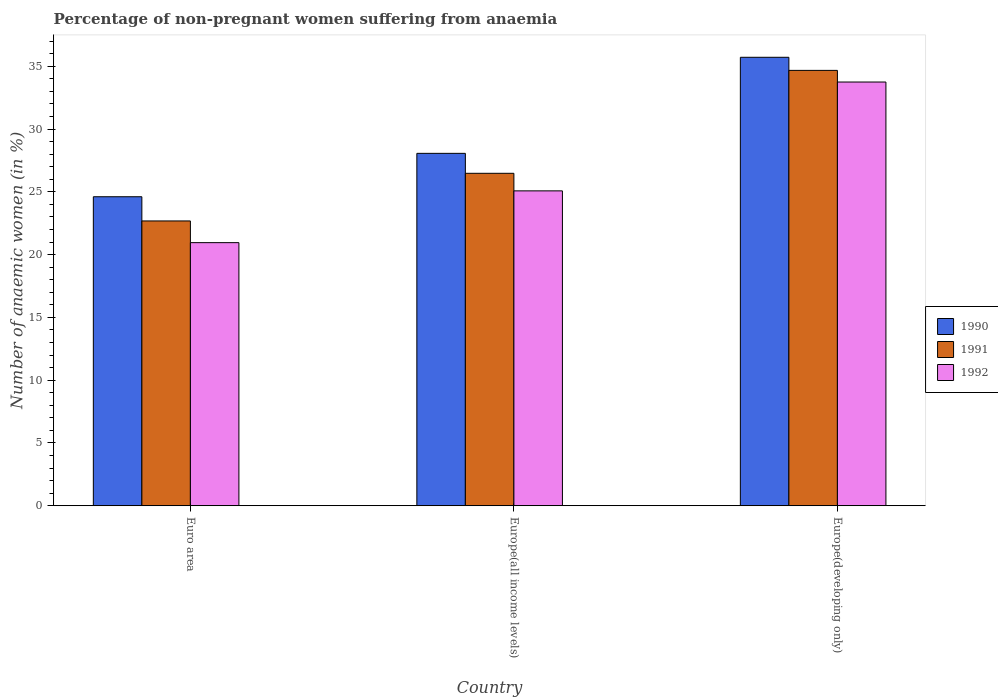How many groups of bars are there?
Keep it short and to the point. 3. What is the label of the 3rd group of bars from the left?
Offer a very short reply. Europe(developing only). What is the percentage of non-pregnant women suffering from anaemia in 1991 in Euro area?
Provide a short and direct response. 22.68. Across all countries, what is the maximum percentage of non-pregnant women suffering from anaemia in 1991?
Ensure brevity in your answer.  34.67. Across all countries, what is the minimum percentage of non-pregnant women suffering from anaemia in 1991?
Offer a very short reply. 22.68. In which country was the percentage of non-pregnant women suffering from anaemia in 1992 maximum?
Your answer should be compact. Europe(developing only). What is the total percentage of non-pregnant women suffering from anaemia in 1992 in the graph?
Keep it short and to the point. 79.77. What is the difference between the percentage of non-pregnant women suffering from anaemia in 1991 in Euro area and that in Europe(developing only)?
Provide a succinct answer. -11.99. What is the difference between the percentage of non-pregnant women suffering from anaemia in 1992 in Europe(developing only) and the percentage of non-pregnant women suffering from anaemia in 1991 in Europe(all income levels)?
Your answer should be compact. 7.27. What is the average percentage of non-pregnant women suffering from anaemia in 1991 per country?
Provide a succinct answer. 27.94. What is the difference between the percentage of non-pregnant women suffering from anaemia of/in 1990 and percentage of non-pregnant women suffering from anaemia of/in 1992 in Europe(developing only)?
Ensure brevity in your answer.  1.97. What is the ratio of the percentage of non-pregnant women suffering from anaemia in 1991 in Europe(all income levels) to that in Europe(developing only)?
Offer a very short reply. 0.76. Is the percentage of non-pregnant women suffering from anaemia in 1991 in Euro area less than that in Europe(developing only)?
Provide a short and direct response. Yes. What is the difference between the highest and the second highest percentage of non-pregnant women suffering from anaemia in 1991?
Ensure brevity in your answer.  8.2. What is the difference between the highest and the lowest percentage of non-pregnant women suffering from anaemia in 1991?
Offer a terse response. 11.99. What does the 2nd bar from the right in Europe(all income levels) represents?
Provide a short and direct response. 1991. How many bars are there?
Offer a terse response. 9. How are the legend labels stacked?
Provide a short and direct response. Vertical. What is the title of the graph?
Ensure brevity in your answer.  Percentage of non-pregnant women suffering from anaemia. What is the label or title of the X-axis?
Give a very brief answer. Country. What is the label or title of the Y-axis?
Make the answer very short. Number of anaemic women (in %). What is the Number of anaemic women (in %) of 1990 in Euro area?
Provide a short and direct response. 24.61. What is the Number of anaemic women (in %) of 1991 in Euro area?
Your answer should be very brief. 22.68. What is the Number of anaemic women (in %) of 1992 in Euro area?
Offer a terse response. 20.95. What is the Number of anaemic women (in %) in 1990 in Europe(all income levels)?
Your answer should be very brief. 28.06. What is the Number of anaemic women (in %) in 1991 in Europe(all income levels)?
Offer a very short reply. 26.47. What is the Number of anaemic women (in %) of 1992 in Europe(all income levels)?
Give a very brief answer. 25.07. What is the Number of anaemic women (in %) of 1990 in Europe(developing only)?
Make the answer very short. 35.71. What is the Number of anaemic women (in %) in 1991 in Europe(developing only)?
Keep it short and to the point. 34.67. What is the Number of anaemic women (in %) in 1992 in Europe(developing only)?
Give a very brief answer. 33.74. Across all countries, what is the maximum Number of anaemic women (in %) of 1990?
Provide a short and direct response. 35.71. Across all countries, what is the maximum Number of anaemic women (in %) in 1991?
Provide a succinct answer. 34.67. Across all countries, what is the maximum Number of anaemic women (in %) in 1992?
Provide a short and direct response. 33.74. Across all countries, what is the minimum Number of anaemic women (in %) of 1990?
Your answer should be compact. 24.61. Across all countries, what is the minimum Number of anaemic women (in %) of 1991?
Offer a terse response. 22.68. Across all countries, what is the minimum Number of anaemic women (in %) of 1992?
Provide a short and direct response. 20.95. What is the total Number of anaemic women (in %) in 1990 in the graph?
Ensure brevity in your answer.  88.38. What is the total Number of anaemic women (in %) in 1991 in the graph?
Your response must be concise. 83.82. What is the total Number of anaemic women (in %) in 1992 in the graph?
Give a very brief answer. 79.77. What is the difference between the Number of anaemic women (in %) of 1990 in Euro area and that in Europe(all income levels)?
Provide a short and direct response. -3.46. What is the difference between the Number of anaemic women (in %) in 1991 in Euro area and that in Europe(all income levels)?
Make the answer very short. -3.79. What is the difference between the Number of anaemic women (in %) in 1992 in Euro area and that in Europe(all income levels)?
Your answer should be compact. -4.12. What is the difference between the Number of anaemic women (in %) in 1990 in Euro area and that in Europe(developing only)?
Your answer should be very brief. -11.1. What is the difference between the Number of anaemic women (in %) of 1991 in Euro area and that in Europe(developing only)?
Your response must be concise. -11.99. What is the difference between the Number of anaemic women (in %) in 1992 in Euro area and that in Europe(developing only)?
Give a very brief answer. -12.79. What is the difference between the Number of anaemic women (in %) of 1990 in Europe(all income levels) and that in Europe(developing only)?
Offer a very short reply. -7.65. What is the difference between the Number of anaemic women (in %) of 1991 in Europe(all income levels) and that in Europe(developing only)?
Keep it short and to the point. -8.2. What is the difference between the Number of anaemic women (in %) of 1992 in Europe(all income levels) and that in Europe(developing only)?
Provide a short and direct response. -8.67. What is the difference between the Number of anaemic women (in %) of 1990 in Euro area and the Number of anaemic women (in %) of 1991 in Europe(all income levels)?
Offer a very short reply. -1.87. What is the difference between the Number of anaemic women (in %) in 1990 in Euro area and the Number of anaemic women (in %) in 1992 in Europe(all income levels)?
Provide a succinct answer. -0.47. What is the difference between the Number of anaemic women (in %) of 1991 in Euro area and the Number of anaemic women (in %) of 1992 in Europe(all income levels)?
Your answer should be compact. -2.39. What is the difference between the Number of anaemic women (in %) in 1990 in Euro area and the Number of anaemic women (in %) in 1991 in Europe(developing only)?
Offer a terse response. -10.06. What is the difference between the Number of anaemic women (in %) in 1990 in Euro area and the Number of anaemic women (in %) in 1992 in Europe(developing only)?
Offer a very short reply. -9.13. What is the difference between the Number of anaemic women (in %) in 1991 in Euro area and the Number of anaemic women (in %) in 1992 in Europe(developing only)?
Provide a succinct answer. -11.06. What is the difference between the Number of anaemic women (in %) in 1990 in Europe(all income levels) and the Number of anaemic women (in %) in 1991 in Europe(developing only)?
Provide a succinct answer. -6.61. What is the difference between the Number of anaemic women (in %) in 1990 in Europe(all income levels) and the Number of anaemic women (in %) in 1992 in Europe(developing only)?
Keep it short and to the point. -5.68. What is the difference between the Number of anaemic women (in %) of 1991 in Europe(all income levels) and the Number of anaemic women (in %) of 1992 in Europe(developing only)?
Offer a very short reply. -7.27. What is the average Number of anaemic women (in %) in 1990 per country?
Your response must be concise. 29.46. What is the average Number of anaemic women (in %) in 1991 per country?
Offer a terse response. 27.94. What is the average Number of anaemic women (in %) of 1992 per country?
Your answer should be very brief. 26.59. What is the difference between the Number of anaemic women (in %) of 1990 and Number of anaemic women (in %) of 1991 in Euro area?
Give a very brief answer. 1.93. What is the difference between the Number of anaemic women (in %) of 1990 and Number of anaemic women (in %) of 1992 in Euro area?
Offer a terse response. 3.66. What is the difference between the Number of anaemic women (in %) of 1991 and Number of anaemic women (in %) of 1992 in Euro area?
Your answer should be very brief. 1.73. What is the difference between the Number of anaemic women (in %) in 1990 and Number of anaemic women (in %) in 1991 in Europe(all income levels)?
Your response must be concise. 1.59. What is the difference between the Number of anaemic women (in %) in 1990 and Number of anaemic women (in %) in 1992 in Europe(all income levels)?
Offer a very short reply. 2.99. What is the difference between the Number of anaemic women (in %) in 1991 and Number of anaemic women (in %) in 1992 in Europe(all income levels)?
Make the answer very short. 1.4. What is the difference between the Number of anaemic women (in %) in 1990 and Number of anaemic women (in %) in 1991 in Europe(developing only)?
Your answer should be very brief. 1.04. What is the difference between the Number of anaemic women (in %) in 1990 and Number of anaemic women (in %) in 1992 in Europe(developing only)?
Provide a succinct answer. 1.97. What is the difference between the Number of anaemic women (in %) of 1991 and Number of anaemic women (in %) of 1992 in Europe(developing only)?
Your answer should be very brief. 0.93. What is the ratio of the Number of anaemic women (in %) of 1990 in Euro area to that in Europe(all income levels)?
Provide a short and direct response. 0.88. What is the ratio of the Number of anaemic women (in %) of 1991 in Euro area to that in Europe(all income levels)?
Provide a succinct answer. 0.86. What is the ratio of the Number of anaemic women (in %) of 1992 in Euro area to that in Europe(all income levels)?
Provide a short and direct response. 0.84. What is the ratio of the Number of anaemic women (in %) of 1990 in Euro area to that in Europe(developing only)?
Offer a terse response. 0.69. What is the ratio of the Number of anaemic women (in %) in 1991 in Euro area to that in Europe(developing only)?
Your answer should be very brief. 0.65. What is the ratio of the Number of anaemic women (in %) of 1992 in Euro area to that in Europe(developing only)?
Give a very brief answer. 0.62. What is the ratio of the Number of anaemic women (in %) of 1990 in Europe(all income levels) to that in Europe(developing only)?
Your response must be concise. 0.79. What is the ratio of the Number of anaemic women (in %) in 1991 in Europe(all income levels) to that in Europe(developing only)?
Your answer should be compact. 0.76. What is the ratio of the Number of anaemic women (in %) of 1992 in Europe(all income levels) to that in Europe(developing only)?
Make the answer very short. 0.74. What is the difference between the highest and the second highest Number of anaemic women (in %) in 1990?
Give a very brief answer. 7.65. What is the difference between the highest and the second highest Number of anaemic women (in %) of 1991?
Your answer should be very brief. 8.2. What is the difference between the highest and the second highest Number of anaemic women (in %) of 1992?
Provide a succinct answer. 8.67. What is the difference between the highest and the lowest Number of anaemic women (in %) of 1990?
Offer a very short reply. 11.1. What is the difference between the highest and the lowest Number of anaemic women (in %) of 1991?
Offer a terse response. 11.99. What is the difference between the highest and the lowest Number of anaemic women (in %) of 1992?
Your answer should be compact. 12.79. 